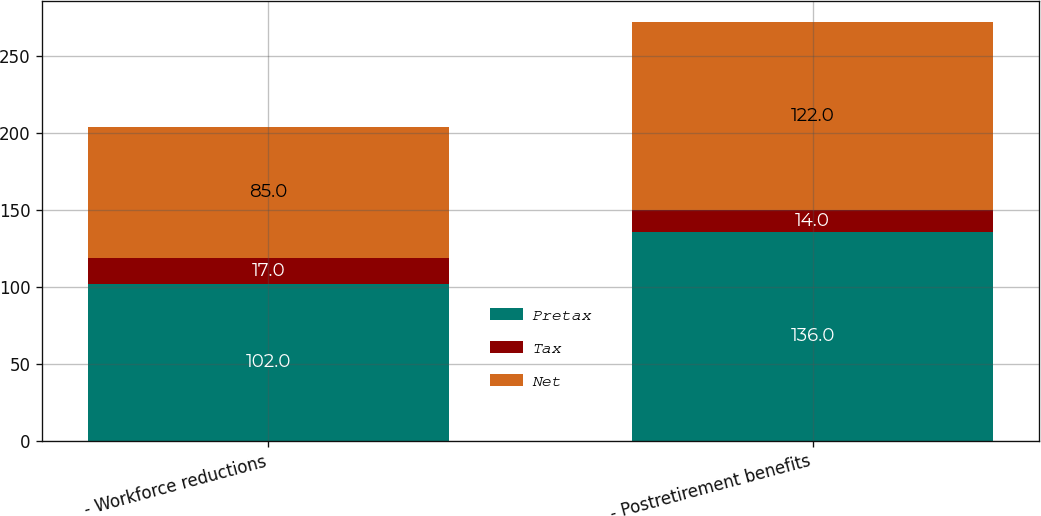Convert chart to OTSL. <chart><loc_0><loc_0><loc_500><loc_500><stacked_bar_chart><ecel><fcel>- Workforce reductions<fcel>- Postretirement benefits<nl><fcel>Pretax<fcel>102<fcel>136<nl><fcel>Tax<fcel>17<fcel>14<nl><fcel>Net<fcel>85<fcel>122<nl></chart> 